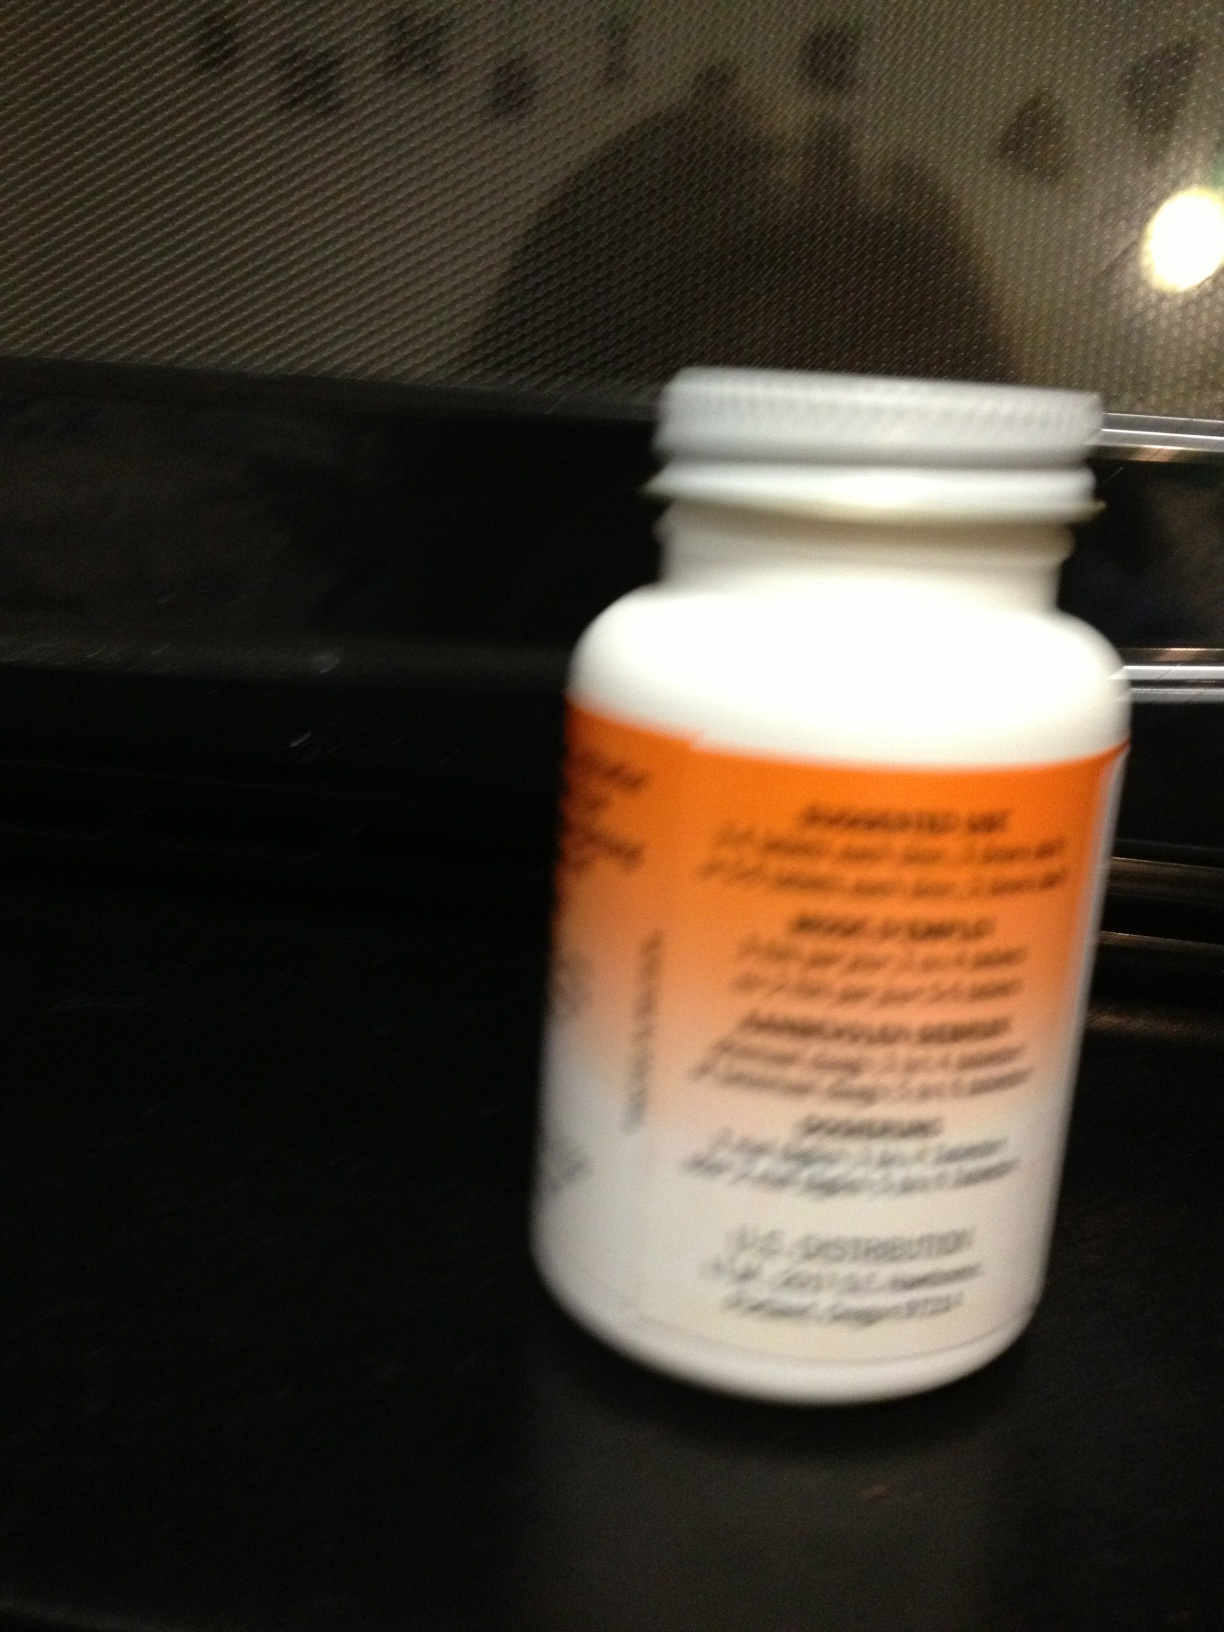What type of medication might be in this type of bottle generally? This type of bottle, with its characteristic orange label and child-proof cap, is commonly used for prescription medications. These can range from antibiotics and pain relievers to chronic condition management drugs like blood pressure or diabetes medications. 